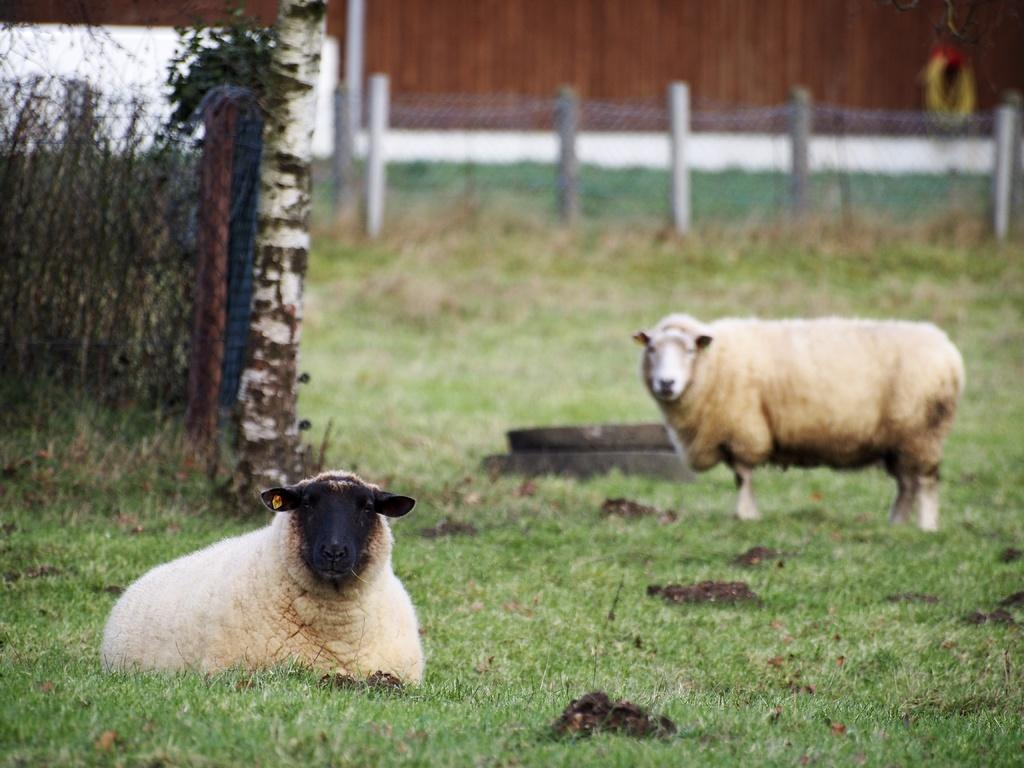How many animals are present in the image? There are two sheep in the image. What is the sheep's environment like? The sheep are on the grass. What can be seen in the background of the image? There is metal fencing in the background of the image. What type of tree can be seen in the image? There is no tree present in the image; it features two sheep on the grass with metal fencing in the background. 